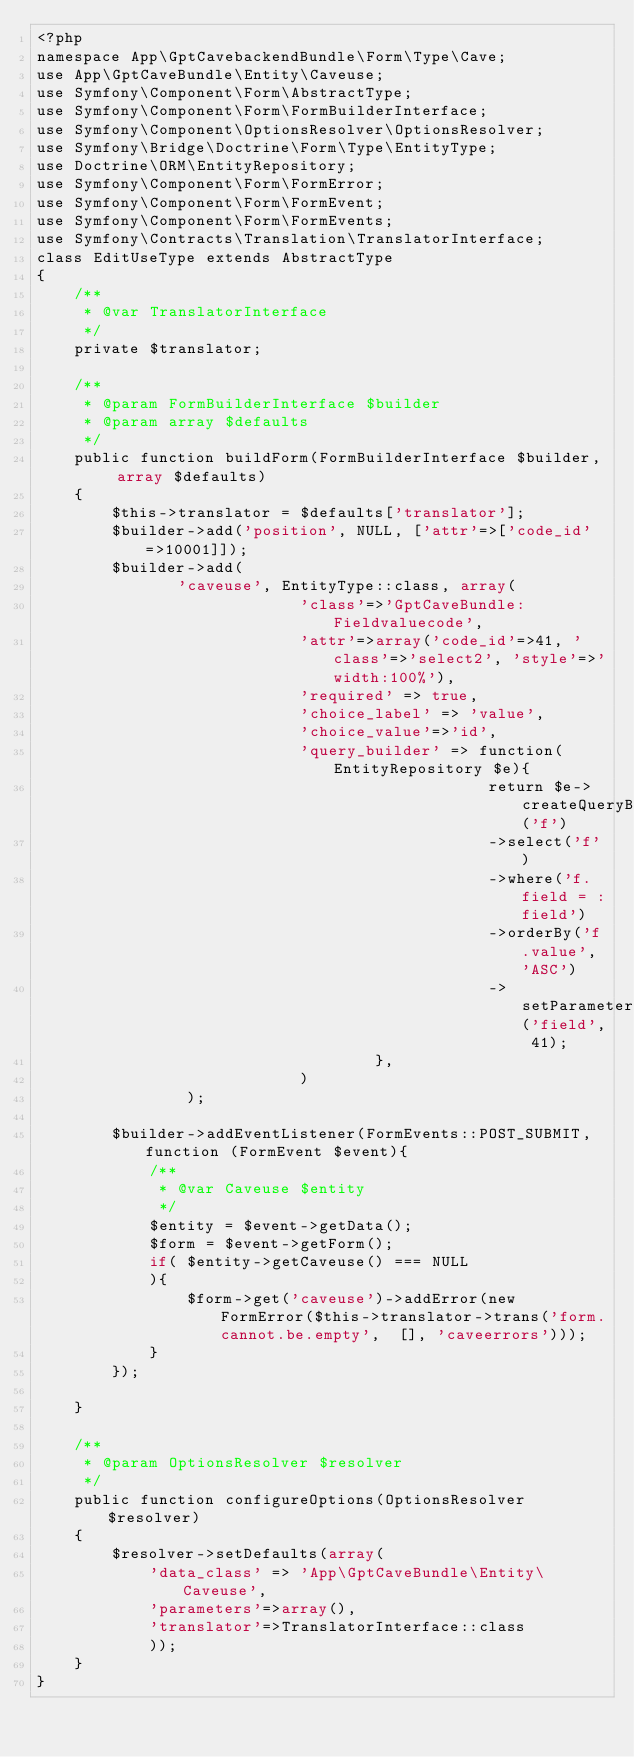<code> <loc_0><loc_0><loc_500><loc_500><_PHP_><?php
namespace App\GptCavebackendBundle\Form\Type\Cave;
use App\GptCaveBundle\Entity\Caveuse;
use Symfony\Component\Form\AbstractType;
use Symfony\Component\Form\FormBuilderInterface;
use Symfony\Component\OptionsResolver\OptionsResolver;
use Symfony\Bridge\Doctrine\Form\Type\EntityType;
use Doctrine\ORM\EntityRepository;
use Symfony\Component\Form\FormError;
use Symfony\Component\Form\FormEvent;
use Symfony\Component\Form\FormEvents;
use Symfony\Contracts\Translation\TranslatorInterface;
class EditUseType extends AbstractType
{
    /**
     * @var TranslatorInterface
     */
    private $translator;
    
    /**
     * @param FormBuilderInterface $builder
     * @param array $defaults
     */
    public function buildForm(FormBuilderInterface $builder, array $defaults)
    {
        $this->translator = $defaults['translator'];
        $builder->add('position', NULL, ['attr'=>['code_id'=>10001]]);
        $builder->add(
               'caveuse', EntityType::class, array(
                            'class'=>'GptCaveBundle:Fieldvaluecode',
                            'attr'=>array('code_id'=>41, 'class'=>'select2', 'style'=>'width:100%'),
                            'required' => true,
                            'choice_label' => 'value',
                            'choice_value'=>'id',
                            'query_builder' => function(EntityRepository $e){
                                                return $e->createQueryBuilder('f')
                                                ->select('f')
                                                ->where('f.field = :field')
                                                ->orderBy('f.value', 'ASC')
                                                ->setParameter('field', 41);
                                    },
                            )
                );

        $builder->addEventListener(FormEvents::POST_SUBMIT, function (FormEvent $event){
            /**
             * @var Caveuse $entity
             */
            $entity = $event->getData();
            $form = $event->getForm();
            if( $entity->getCaveuse() === NULL
            ){
                $form->get('caveuse')->addError(new FormError($this->translator->trans('form.cannot.be.empty',  [], 'caveerrors')));
            }
        });

    }

    /**
     * @param OptionsResolver $resolver
     */
    public function configureOptions(OptionsResolver $resolver)
    {
        $resolver->setDefaults(array(
            'data_class' => 'App\GptCaveBundle\Entity\Caveuse',
            'parameters'=>array(),
            'translator'=>TranslatorInterface::class
            ));
    }
}


</code> 